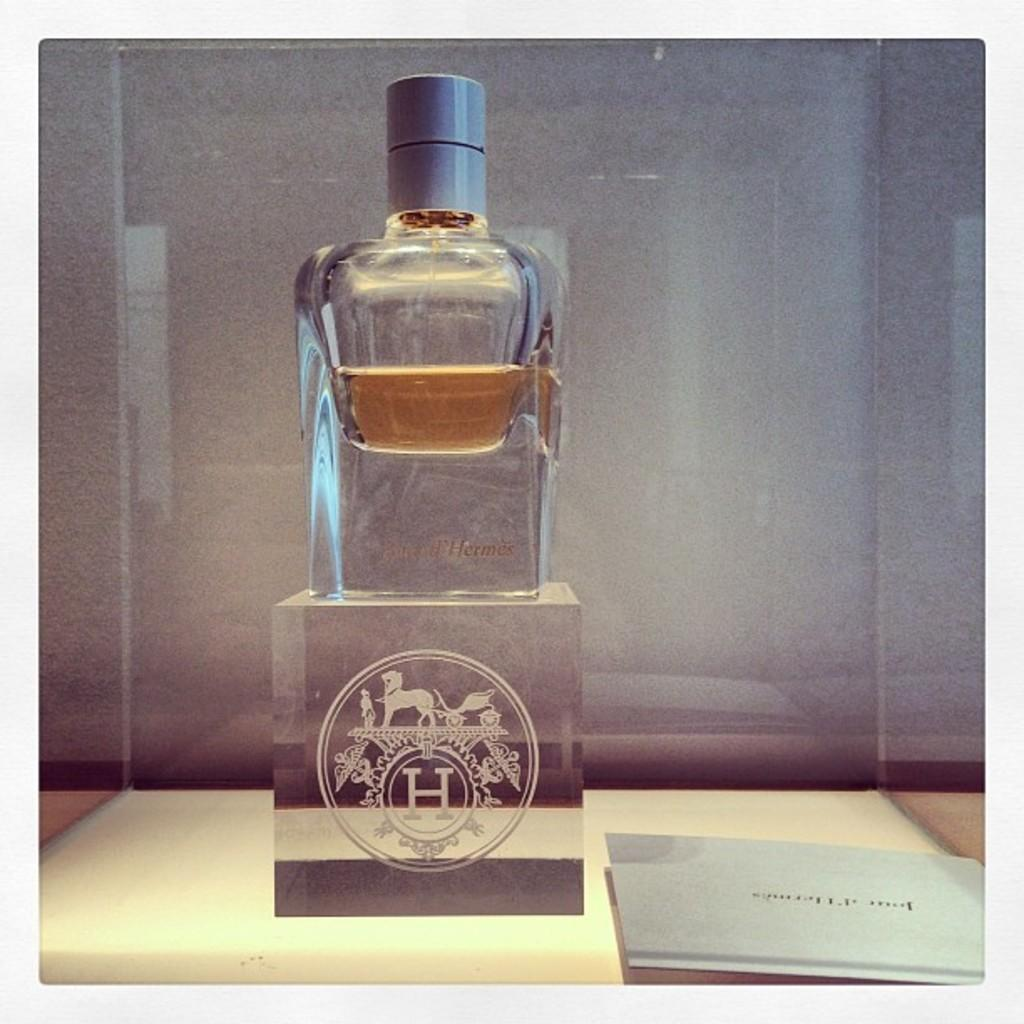<image>
Summarize the visual content of the image. Empty bottle on top of a clear cube with the letter H on it. 